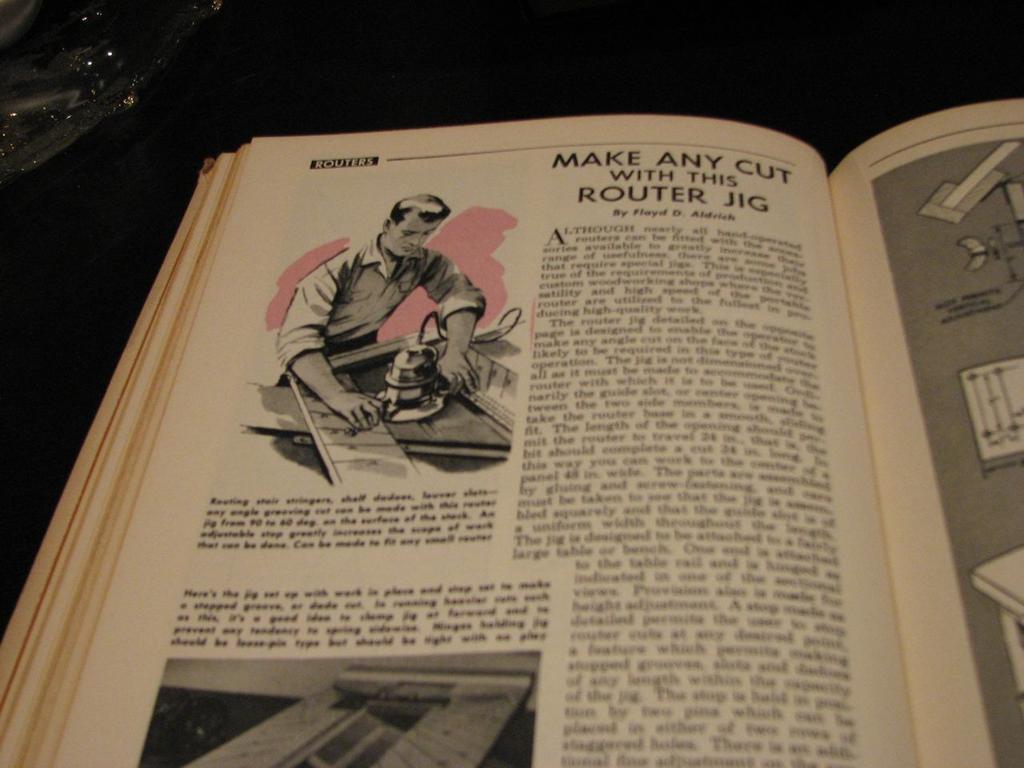What is the man doing?
Keep it short and to the point. Cutting with a router. 